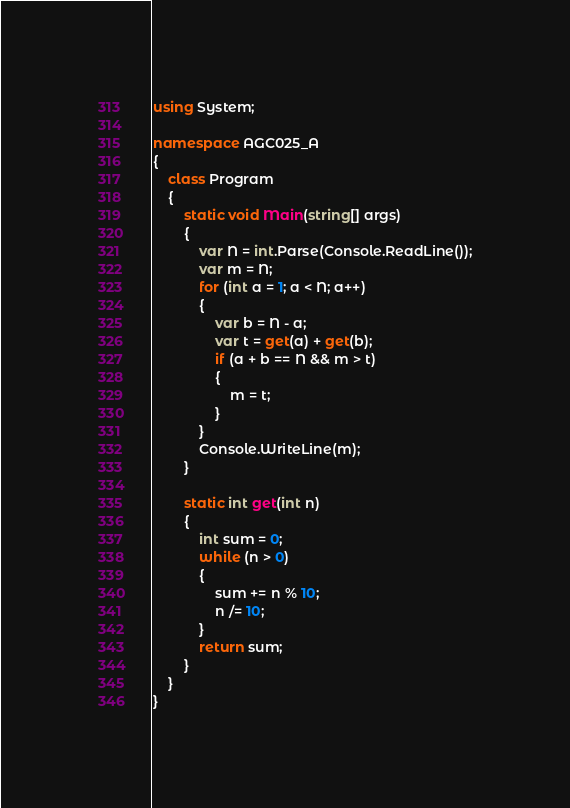Convert code to text. <code><loc_0><loc_0><loc_500><loc_500><_C#_>using System;

namespace AGC025_A
{
    class Program
    {
        static void Main(string[] args)
        {
            var N = int.Parse(Console.ReadLine());
            var m = N;
            for (int a = 1; a < N; a++)
            {
                var b = N - a;
                var t = get(a) + get(b);
                if (a + b == N && m > t)
                {
                    m = t;
                }
            }
            Console.WriteLine(m);
        }

        static int get(int n)
        {
            int sum = 0;
            while (n > 0)
            {
                sum += n % 10;
                n /= 10;
            }
            return sum;
        }
    }
}
</code> 